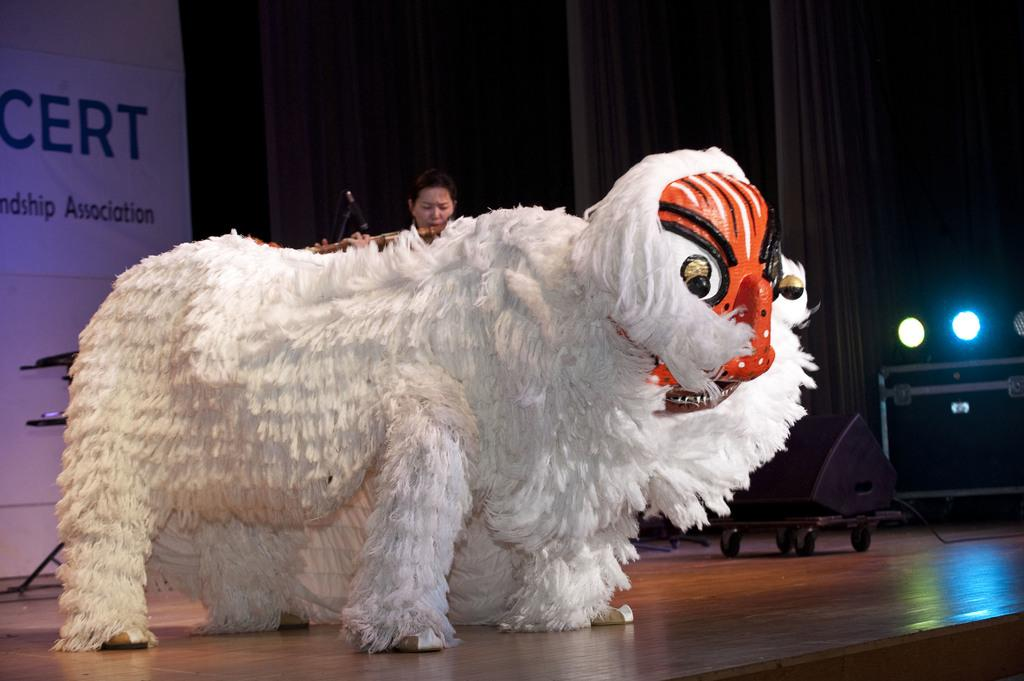What type of doll is in the image? There is a doll in the shape of a sheep in the image. What color is the doll? The doll is white in color. Who is looking at the doll? A woman is looking at the doll. What can be seen on the right side of the image? There are plants on the right side of the image. What type of chalk is being used to draw on the doll? There is no chalk present in the image, and the doll is not being drawn on. How many books are visible in the image? There are no books visible in the image. 